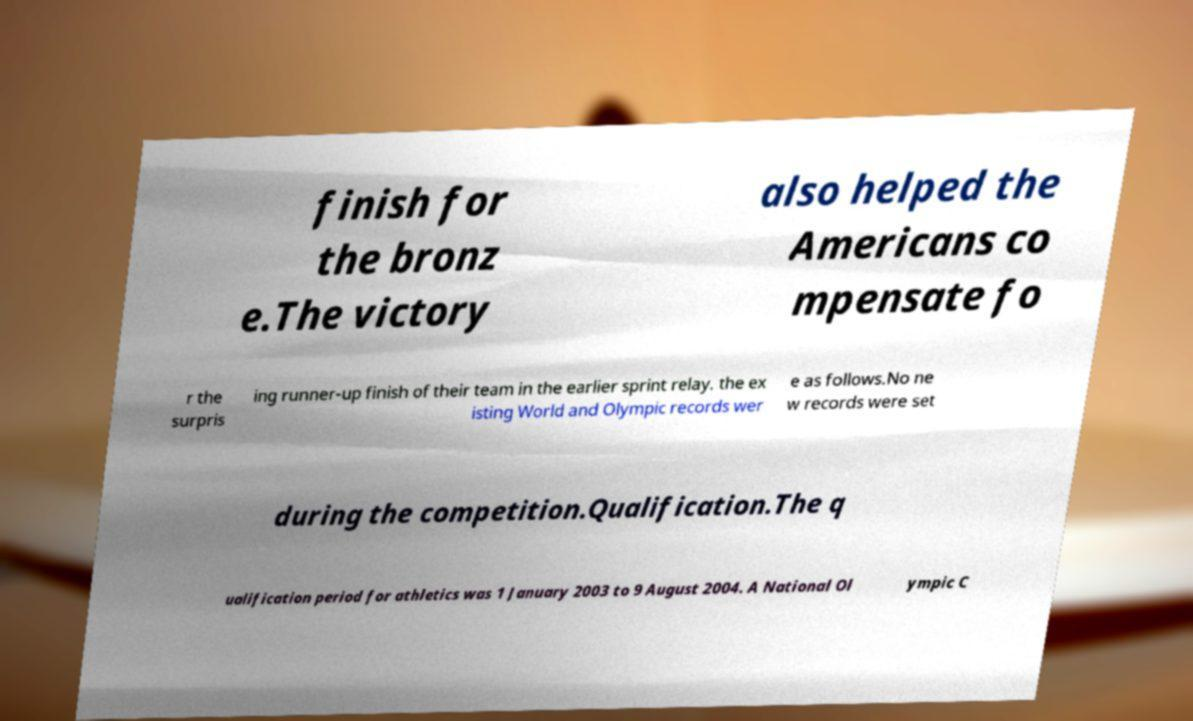Could you assist in decoding the text presented in this image and type it out clearly? finish for the bronz e.The victory also helped the Americans co mpensate fo r the surpris ing runner-up finish of their team in the earlier sprint relay. the ex isting World and Olympic records wer e as follows.No ne w records were set during the competition.Qualification.The q ualification period for athletics was 1 January 2003 to 9 August 2004. A National Ol ympic C 